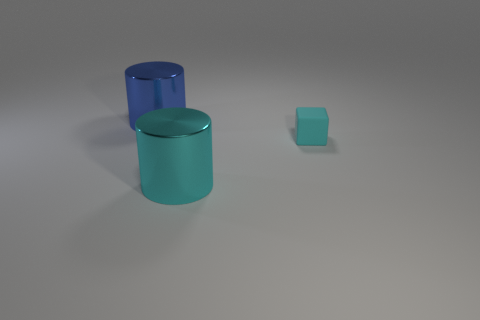Add 3 cyan things. How many objects exist? 6 Subtract all cubes. How many objects are left? 2 Add 3 big objects. How many big objects exist? 5 Subtract 0 gray blocks. How many objects are left? 3 Subtract all big yellow matte things. Subtract all large cyan metallic objects. How many objects are left? 2 Add 3 cyan cubes. How many cyan cubes are left? 4 